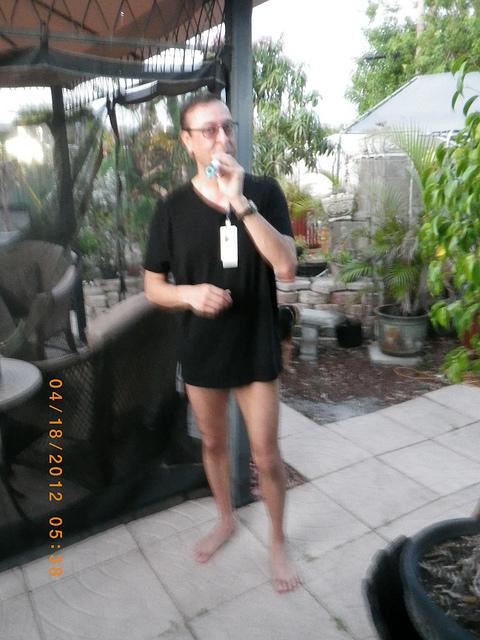What color is the man's shirt?
Answer briefly. Black. Is this man properly equipped to walk on glass?
Concise answer only. No. What is the person holding?
Answer briefly. Whistle. Will the man make you a meal?
Concise answer only. No. 